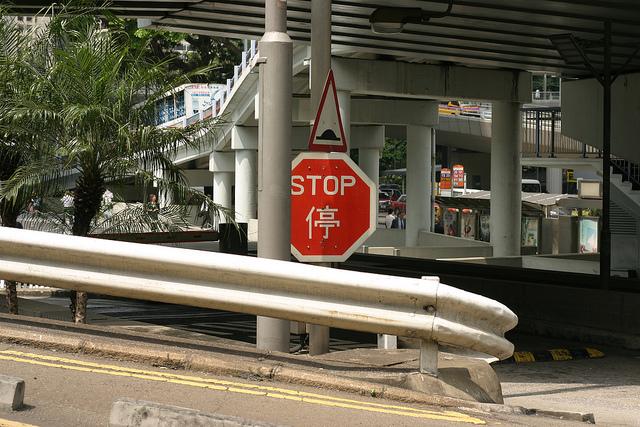What does this sign say?
Short answer required. Stop. Why are there two languages on the sign?
Write a very short answer. For tourists. What color is the sign?
Write a very short answer. Red. 